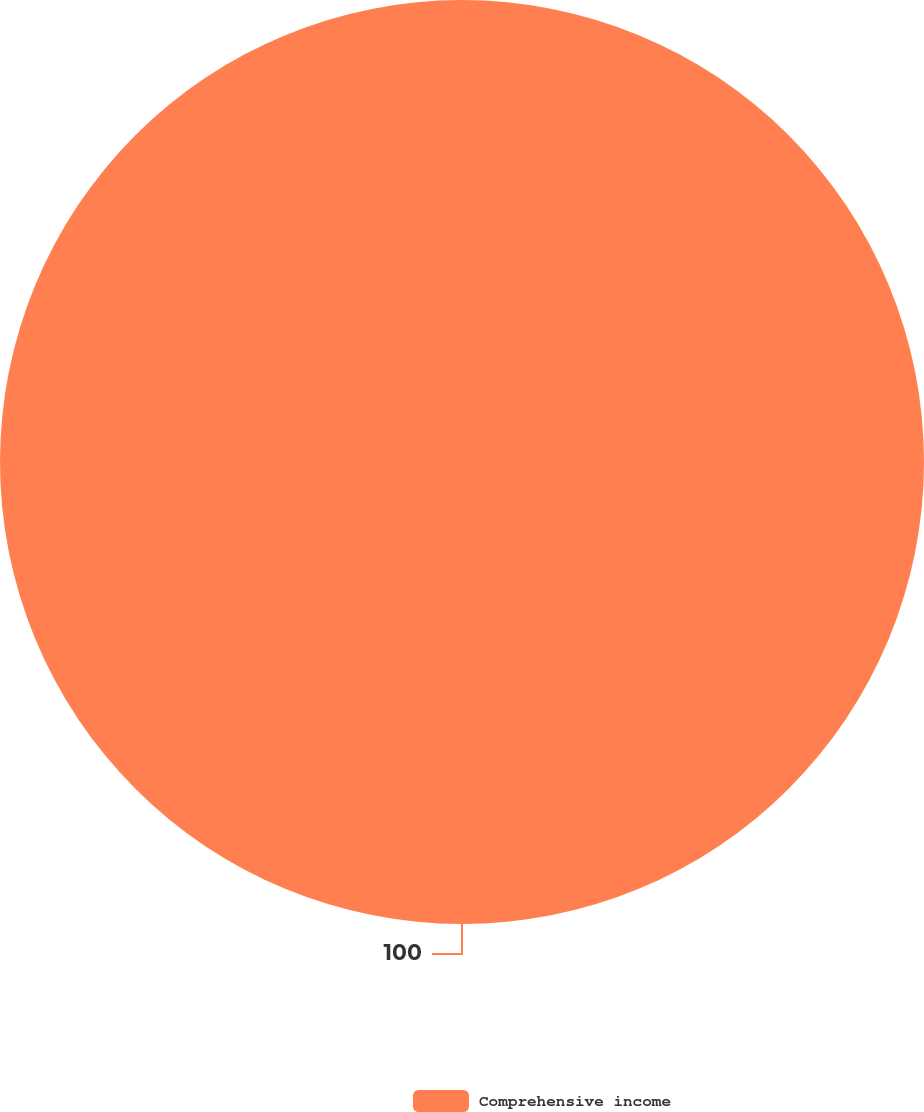Convert chart. <chart><loc_0><loc_0><loc_500><loc_500><pie_chart><fcel>Comprehensive income<nl><fcel>100.0%<nl></chart> 